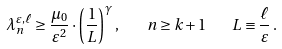Convert formula to latex. <formula><loc_0><loc_0><loc_500><loc_500>\lambda _ { n } ^ { \varepsilon , \ell } \geq \frac { \mu _ { 0 } } { \varepsilon ^ { 2 } } \cdot \left ( \frac { 1 } { L } \right ) ^ { \gamma } , \quad n \geq k + 1 \quad L \equiv \frac { \ell } { \varepsilon } \, .</formula> 